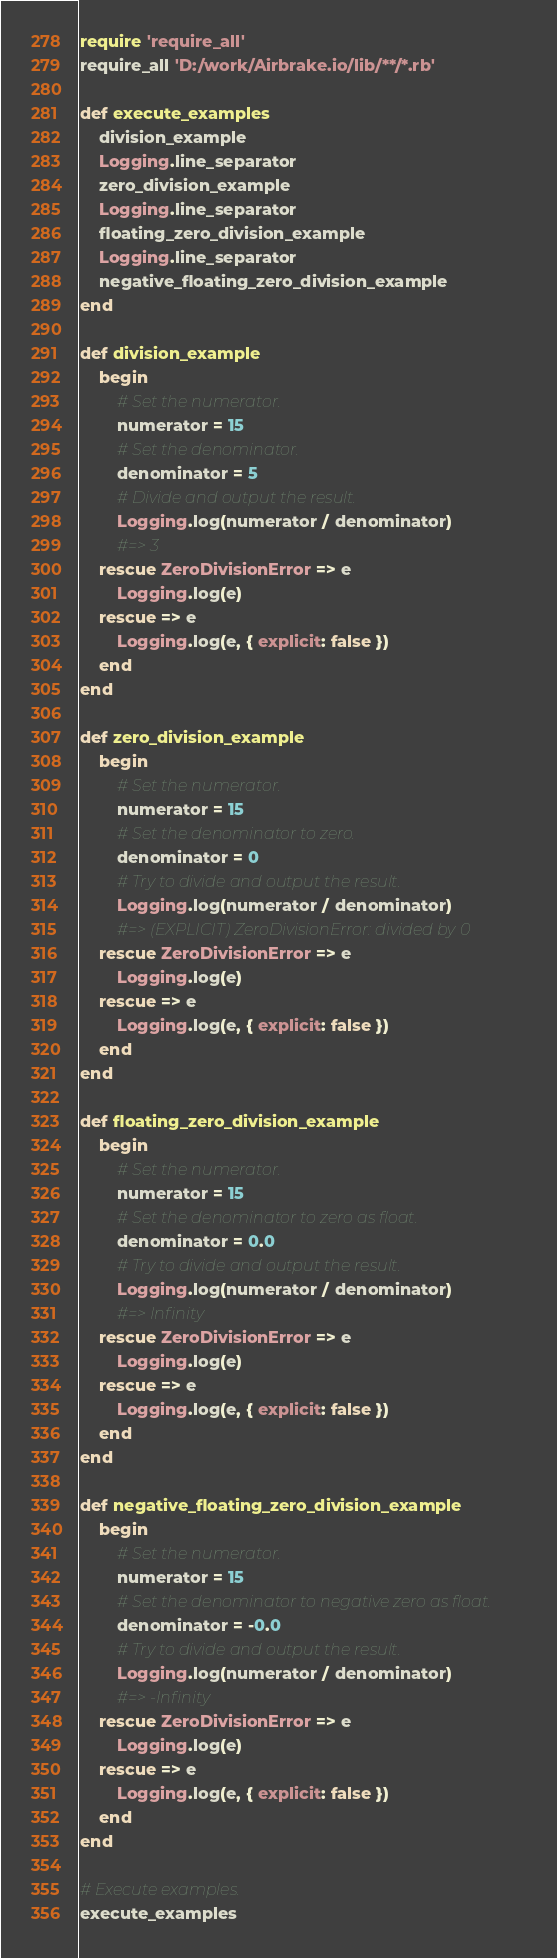Convert code to text. <code><loc_0><loc_0><loc_500><loc_500><_Ruby_>require 'require_all'
require_all 'D:/work/Airbrake.io/lib/**/*.rb'

def execute_examples
    division_example
    Logging.line_separator
    zero_division_example
    Logging.line_separator
    floating_zero_division_example
    Logging.line_separator
    negative_floating_zero_division_example
end

def division_example
    begin
        # Set the numerator.
        numerator = 15
        # Set the denominator.
        denominator = 5
        # Divide and output the result.
        Logging.log(numerator / denominator)
        #=> 3
    rescue ZeroDivisionError => e
        Logging.log(e)
    rescue => e
        Logging.log(e, { explicit: false })
    end    
end

def zero_division_example
    begin
        # Set the numerator.
        numerator = 15
        # Set the denominator to zero.
        denominator = 0
        # Try to divide and output the result.
        Logging.log(numerator / denominator)
        #=> (EXPLICIT) ZeroDivisionError: divided by 0
    rescue ZeroDivisionError => e
        Logging.log(e)
    rescue => e
        Logging.log(e, { explicit: false })
    end    
end

def floating_zero_division_example
    begin
        # Set the numerator.
        numerator = 15
        # Set the denominator to zero as float.
        denominator = 0.0
        # Try to divide and output the result.
        Logging.log(numerator / denominator)
        #=> Infinity
    rescue ZeroDivisionError => e
        Logging.log(e)
    rescue => e
        Logging.log(e, { explicit: false })
    end    
end

def negative_floating_zero_division_example
    begin
        # Set the numerator.
        numerator = 15
        # Set the denominator to negative zero as float.
        denominator = -0.0
        # Try to divide and output the result.
        Logging.log(numerator / denominator)
        #=> -Infinity
    rescue ZeroDivisionError => e
        Logging.log(e)
    rescue => e
        Logging.log(e, { explicit: false })
    end    
end

# Execute examples.
execute_examples</code> 